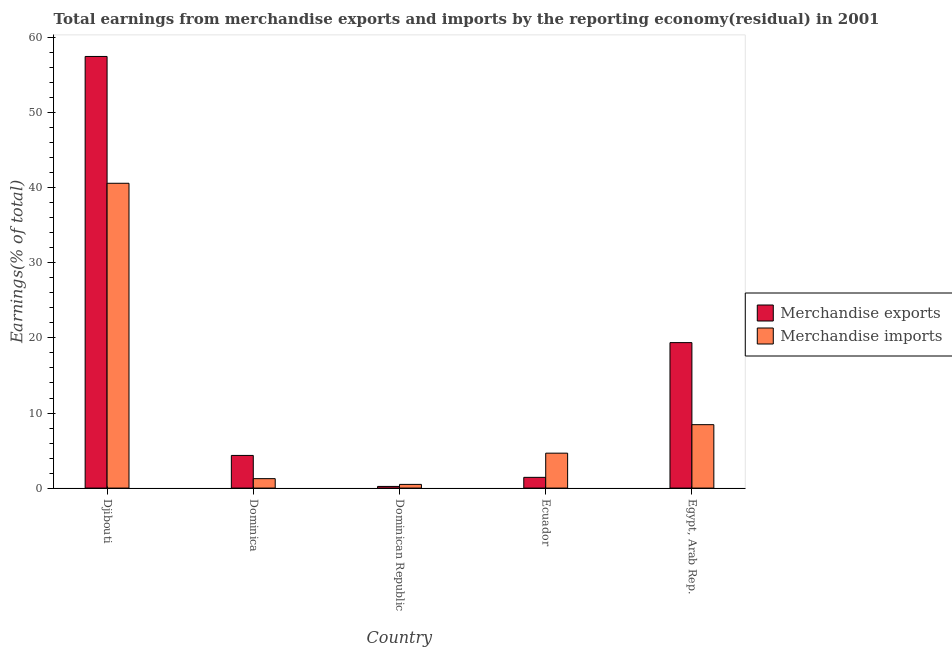How many groups of bars are there?
Offer a very short reply. 5. How many bars are there on the 1st tick from the left?
Provide a short and direct response. 2. What is the label of the 5th group of bars from the left?
Offer a very short reply. Egypt, Arab Rep. In how many cases, is the number of bars for a given country not equal to the number of legend labels?
Keep it short and to the point. 0. What is the earnings from merchandise imports in Djibouti?
Give a very brief answer. 40.61. Across all countries, what is the maximum earnings from merchandise exports?
Your answer should be very brief. 57.5. Across all countries, what is the minimum earnings from merchandise imports?
Make the answer very short. 0.49. In which country was the earnings from merchandise imports maximum?
Provide a succinct answer. Djibouti. In which country was the earnings from merchandise imports minimum?
Your answer should be compact. Dominican Republic. What is the total earnings from merchandise imports in the graph?
Keep it short and to the point. 55.46. What is the difference between the earnings from merchandise imports in Ecuador and that in Egypt, Arab Rep.?
Provide a short and direct response. -3.8. What is the difference between the earnings from merchandise exports in Djibouti and the earnings from merchandise imports in Dominican Republic?
Keep it short and to the point. 57.01. What is the average earnings from merchandise imports per country?
Your answer should be compact. 11.09. What is the difference between the earnings from merchandise imports and earnings from merchandise exports in Djibouti?
Keep it short and to the point. -16.89. What is the ratio of the earnings from merchandise imports in Dominican Republic to that in Ecuador?
Give a very brief answer. 0.11. Is the difference between the earnings from merchandise exports in Djibouti and Egypt, Arab Rep. greater than the difference between the earnings from merchandise imports in Djibouti and Egypt, Arab Rep.?
Give a very brief answer. Yes. What is the difference between the highest and the second highest earnings from merchandise imports?
Provide a succinct answer. 32.16. What is the difference between the highest and the lowest earnings from merchandise exports?
Offer a very short reply. 57.28. What does the 2nd bar from the left in Ecuador represents?
Give a very brief answer. Merchandise imports. How many bars are there?
Provide a succinct answer. 10. Are all the bars in the graph horizontal?
Make the answer very short. No. What is the difference between two consecutive major ticks on the Y-axis?
Ensure brevity in your answer.  10. What is the title of the graph?
Make the answer very short. Total earnings from merchandise exports and imports by the reporting economy(residual) in 2001. What is the label or title of the Y-axis?
Your response must be concise. Earnings(% of total). What is the Earnings(% of total) of Merchandise exports in Djibouti?
Offer a very short reply. 57.5. What is the Earnings(% of total) in Merchandise imports in Djibouti?
Keep it short and to the point. 40.61. What is the Earnings(% of total) in Merchandise exports in Dominica?
Provide a short and direct response. 4.35. What is the Earnings(% of total) of Merchandise imports in Dominica?
Your response must be concise. 1.26. What is the Earnings(% of total) in Merchandise exports in Dominican Republic?
Your response must be concise. 0.22. What is the Earnings(% of total) of Merchandise imports in Dominican Republic?
Offer a terse response. 0.49. What is the Earnings(% of total) in Merchandise exports in Ecuador?
Keep it short and to the point. 1.43. What is the Earnings(% of total) of Merchandise imports in Ecuador?
Your response must be concise. 4.65. What is the Earnings(% of total) of Merchandise exports in Egypt, Arab Rep.?
Make the answer very short. 19.38. What is the Earnings(% of total) of Merchandise imports in Egypt, Arab Rep.?
Keep it short and to the point. 8.45. Across all countries, what is the maximum Earnings(% of total) in Merchandise exports?
Give a very brief answer. 57.5. Across all countries, what is the maximum Earnings(% of total) in Merchandise imports?
Offer a very short reply. 40.61. Across all countries, what is the minimum Earnings(% of total) in Merchandise exports?
Give a very brief answer. 0.22. Across all countries, what is the minimum Earnings(% of total) in Merchandise imports?
Your answer should be compact. 0.49. What is the total Earnings(% of total) of Merchandise exports in the graph?
Keep it short and to the point. 82.88. What is the total Earnings(% of total) of Merchandise imports in the graph?
Your answer should be very brief. 55.46. What is the difference between the Earnings(% of total) of Merchandise exports in Djibouti and that in Dominica?
Your answer should be very brief. 53.15. What is the difference between the Earnings(% of total) of Merchandise imports in Djibouti and that in Dominica?
Provide a short and direct response. 39.35. What is the difference between the Earnings(% of total) in Merchandise exports in Djibouti and that in Dominican Republic?
Your answer should be very brief. 57.28. What is the difference between the Earnings(% of total) in Merchandise imports in Djibouti and that in Dominican Republic?
Offer a very short reply. 40.11. What is the difference between the Earnings(% of total) in Merchandise exports in Djibouti and that in Ecuador?
Ensure brevity in your answer.  56.07. What is the difference between the Earnings(% of total) in Merchandise imports in Djibouti and that in Ecuador?
Provide a short and direct response. 35.95. What is the difference between the Earnings(% of total) of Merchandise exports in Djibouti and that in Egypt, Arab Rep.?
Your response must be concise. 38.12. What is the difference between the Earnings(% of total) in Merchandise imports in Djibouti and that in Egypt, Arab Rep.?
Offer a very short reply. 32.16. What is the difference between the Earnings(% of total) in Merchandise exports in Dominica and that in Dominican Republic?
Your response must be concise. 4.13. What is the difference between the Earnings(% of total) of Merchandise imports in Dominica and that in Dominican Republic?
Provide a short and direct response. 0.77. What is the difference between the Earnings(% of total) in Merchandise exports in Dominica and that in Ecuador?
Ensure brevity in your answer.  2.92. What is the difference between the Earnings(% of total) of Merchandise imports in Dominica and that in Ecuador?
Offer a terse response. -3.39. What is the difference between the Earnings(% of total) in Merchandise exports in Dominica and that in Egypt, Arab Rep.?
Your answer should be compact. -15.03. What is the difference between the Earnings(% of total) in Merchandise imports in Dominica and that in Egypt, Arab Rep.?
Make the answer very short. -7.19. What is the difference between the Earnings(% of total) in Merchandise exports in Dominican Republic and that in Ecuador?
Make the answer very short. -1.21. What is the difference between the Earnings(% of total) in Merchandise imports in Dominican Republic and that in Ecuador?
Offer a very short reply. -4.16. What is the difference between the Earnings(% of total) in Merchandise exports in Dominican Republic and that in Egypt, Arab Rep.?
Ensure brevity in your answer.  -19.16. What is the difference between the Earnings(% of total) in Merchandise imports in Dominican Republic and that in Egypt, Arab Rep.?
Offer a terse response. -7.96. What is the difference between the Earnings(% of total) of Merchandise exports in Ecuador and that in Egypt, Arab Rep.?
Your answer should be very brief. -17.95. What is the difference between the Earnings(% of total) in Merchandise imports in Ecuador and that in Egypt, Arab Rep.?
Provide a short and direct response. -3.8. What is the difference between the Earnings(% of total) of Merchandise exports in Djibouti and the Earnings(% of total) of Merchandise imports in Dominica?
Provide a short and direct response. 56.24. What is the difference between the Earnings(% of total) in Merchandise exports in Djibouti and the Earnings(% of total) in Merchandise imports in Dominican Republic?
Provide a short and direct response. 57.01. What is the difference between the Earnings(% of total) of Merchandise exports in Djibouti and the Earnings(% of total) of Merchandise imports in Ecuador?
Offer a terse response. 52.85. What is the difference between the Earnings(% of total) of Merchandise exports in Djibouti and the Earnings(% of total) of Merchandise imports in Egypt, Arab Rep.?
Offer a terse response. 49.05. What is the difference between the Earnings(% of total) of Merchandise exports in Dominica and the Earnings(% of total) of Merchandise imports in Dominican Republic?
Offer a terse response. 3.86. What is the difference between the Earnings(% of total) in Merchandise exports in Dominica and the Earnings(% of total) in Merchandise imports in Ecuador?
Make the answer very short. -0.3. What is the difference between the Earnings(% of total) of Merchandise exports in Dominica and the Earnings(% of total) of Merchandise imports in Egypt, Arab Rep.?
Ensure brevity in your answer.  -4.1. What is the difference between the Earnings(% of total) in Merchandise exports in Dominican Republic and the Earnings(% of total) in Merchandise imports in Ecuador?
Ensure brevity in your answer.  -4.43. What is the difference between the Earnings(% of total) in Merchandise exports in Dominican Republic and the Earnings(% of total) in Merchandise imports in Egypt, Arab Rep.?
Provide a succinct answer. -8.23. What is the difference between the Earnings(% of total) of Merchandise exports in Ecuador and the Earnings(% of total) of Merchandise imports in Egypt, Arab Rep.?
Provide a succinct answer. -7.02. What is the average Earnings(% of total) in Merchandise exports per country?
Keep it short and to the point. 16.58. What is the average Earnings(% of total) of Merchandise imports per country?
Give a very brief answer. 11.09. What is the difference between the Earnings(% of total) of Merchandise exports and Earnings(% of total) of Merchandise imports in Djibouti?
Provide a short and direct response. 16.89. What is the difference between the Earnings(% of total) in Merchandise exports and Earnings(% of total) in Merchandise imports in Dominica?
Provide a succinct answer. 3.09. What is the difference between the Earnings(% of total) of Merchandise exports and Earnings(% of total) of Merchandise imports in Dominican Republic?
Ensure brevity in your answer.  -0.27. What is the difference between the Earnings(% of total) in Merchandise exports and Earnings(% of total) in Merchandise imports in Ecuador?
Ensure brevity in your answer.  -3.22. What is the difference between the Earnings(% of total) in Merchandise exports and Earnings(% of total) in Merchandise imports in Egypt, Arab Rep.?
Offer a terse response. 10.93. What is the ratio of the Earnings(% of total) in Merchandise exports in Djibouti to that in Dominica?
Offer a terse response. 13.22. What is the ratio of the Earnings(% of total) of Merchandise imports in Djibouti to that in Dominica?
Ensure brevity in your answer.  32.27. What is the ratio of the Earnings(% of total) in Merchandise exports in Djibouti to that in Dominican Republic?
Offer a very short reply. 259.92. What is the ratio of the Earnings(% of total) in Merchandise imports in Djibouti to that in Dominican Republic?
Provide a succinct answer. 82.5. What is the ratio of the Earnings(% of total) in Merchandise exports in Djibouti to that in Ecuador?
Your answer should be compact. 40.21. What is the ratio of the Earnings(% of total) in Merchandise imports in Djibouti to that in Ecuador?
Your answer should be compact. 8.73. What is the ratio of the Earnings(% of total) in Merchandise exports in Djibouti to that in Egypt, Arab Rep.?
Keep it short and to the point. 2.97. What is the ratio of the Earnings(% of total) in Merchandise imports in Djibouti to that in Egypt, Arab Rep.?
Give a very brief answer. 4.81. What is the ratio of the Earnings(% of total) of Merchandise exports in Dominica to that in Dominican Republic?
Provide a short and direct response. 19.67. What is the ratio of the Earnings(% of total) in Merchandise imports in Dominica to that in Dominican Republic?
Keep it short and to the point. 2.56. What is the ratio of the Earnings(% of total) in Merchandise exports in Dominica to that in Ecuador?
Keep it short and to the point. 3.04. What is the ratio of the Earnings(% of total) of Merchandise imports in Dominica to that in Ecuador?
Provide a short and direct response. 0.27. What is the ratio of the Earnings(% of total) of Merchandise exports in Dominica to that in Egypt, Arab Rep.?
Give a very brief answer. 0.22. What is the ratio of the Earnings(% of total) in Merchandise imports in Dominica to that in Egypt, Arab Rep.?
Keep it short and to the point. 0.15. What is the ratio of the Earnings(% of total) in Merchandise exports in Dominican Republic to that in Ecuador?
Give a very brief answer. 0.15. What is the ratio of the Earnings(% of total) of Merchandise imports in Dominican Republic to that in Ecuador?
Your answer should be compact. 0.11. What is the ratio of the Earnings(% of total) in Merchandise exports in Dominican Republic to that in Egypt, Arab Rep.?
Make the answer very short. 0.01. What is the ratio of the Earnings(% of total) of Merchandise imports in Dominican Republic to that in Egypt, Arab Rep.?
Make the answer very short. 0.06. What is the ratio of the Earnings(% of total) of Merchandise exports in Ecuador to that in Egypt, Arab Rep.?
Offer a terse response. 0.07. What is the ratio of the Earnings(% of total) of Merchandise imports in Ecuador to that in Egypt, Arab Rep.?
Offer a terse response. 0.55. What is the difference between the highest and the second highest Earnings(% of total) in Merchandise exports?
Provide a short and direct response. 38.12. What is the difference between the highest and the second highest Earnings(% of total) of Merchandise imports?
Keep it short and to the point. 32.16. What is the difference between the highest and the lowest Earnings(% of total) of Merchandise exports?
Your answer should be very brief. 57.28. What is the difference between the highest and the lowest Earnings(% of total) in Merchandise imports?
Keep it short and to the point. 40.11. 